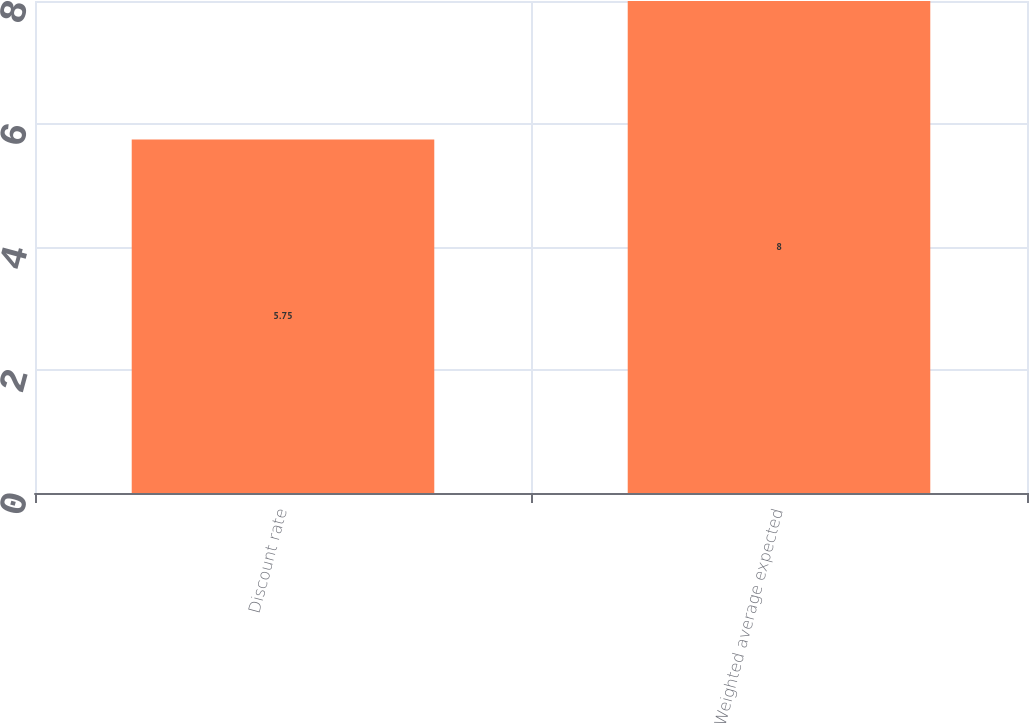<chart> <loc_0><loc_0><loc_500><loc_500><bar_chart><fcel>Discount rate<fcel>Weighted average expected<nl><fcel>5.75<fcel>8<nl></chart> 